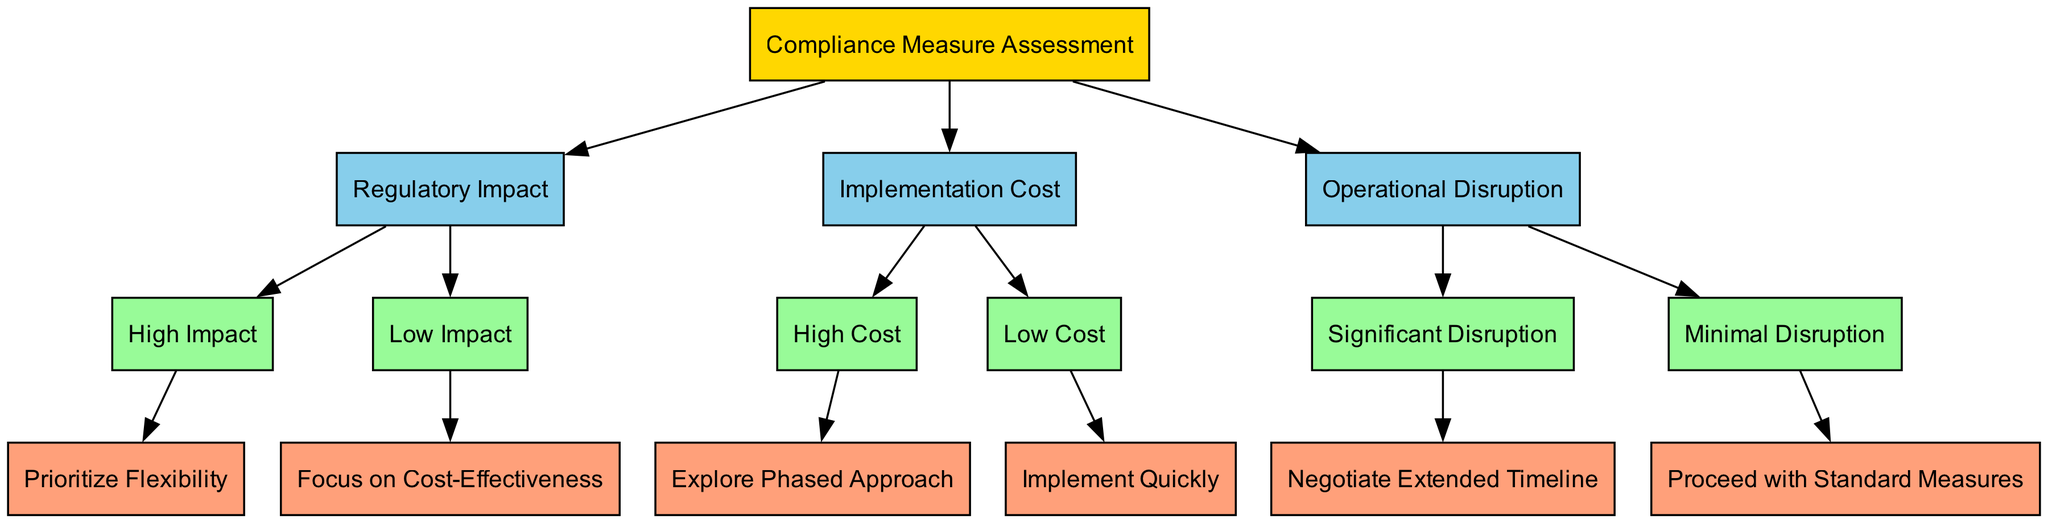What is the root node of the diagram? The root node of the diagram is labeled "Compliance Measure Assessment," which is the starting point for evaluating compliance measures.
Answer: Compliance Measure Assessment How many main nodes are there under the root node? There are three main nodes directly connected to the root node, which are "Regulatory Impact," "Implementation Cost," and "Operational Disruption."
Answer: 3 What does the "High Impact" node lead to? The "High Impact" node leads to the child node labeled "Prioritize Flexibility," indicating the next step when regulatory impact is high.
Answer: Prioritize Flexibility Which node corresponds to significant operational disruption? The node corresponding to significant operational disruption is "Significant Disruption," which indicates a specific level of disruption that guides the next decision.
Answer: Significant Disruption If the implementation cost is high, what approach is suggested? If the implementation cost is high, the suggested approach is to "Explore Phased Approach," which provides a strategy for managing high costs.
Answer: Explore Phased Approach What happens after "Low Cost" is identified? After "Low Cost" is identified, the next step is to "Implement Quickly," which indicates an efficient response to low costs associated with compliance measures.
Answer: Implement Quickly What are the two outcomes stemming from "Regulatory Impact"? The two outcomes stemming from "Regulatory Impact" are "High Impact" and "Low Impact," which guide the decision-making process based on the level of regulatory impact.
Answer: High Impact, Low Impact What decision is made for minimal operational disruption? For minimal operational disruption, the decision is to "Proceed with Standard Measures," indicating a straightforward approach for compliance.
Answer: Proceed with Standard Measures How is flexibility prioritized based on regulatory impact? Flexibility is prioritized based on regulatory impact by directing attention to the "Prioritize Flexibility" action if the impact is deemed high, indicating a strategic response.
Answer: Prioritize Flexibility 